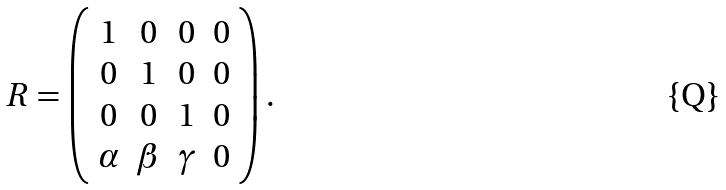<formula> <loc_0><loc_0><loc_500><loc_500>R = \left ( \begin{array} { c c c c } 1 & 0 & 0 & 0 \\ 0 & 1 & 0 & 0 \\ 0 & 0 & 1 & 0 \\ \alpha & \beta & \gamma & 0 \end{array} \right ) .</formula> 